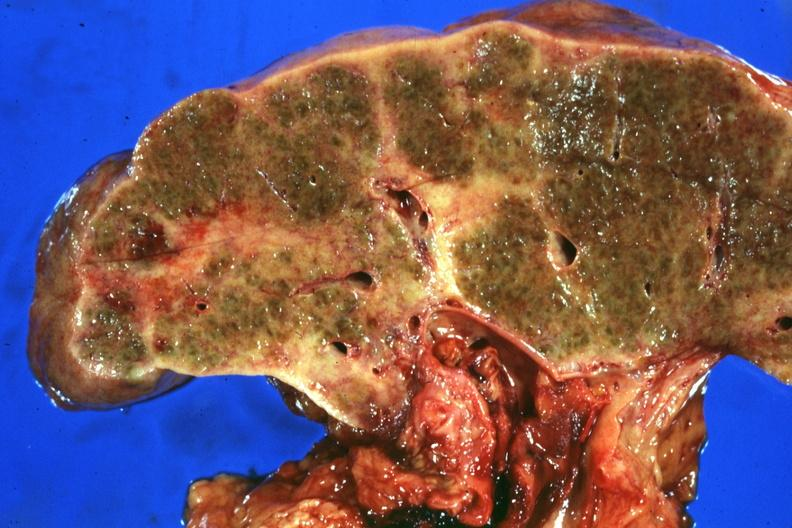s exact cause present?
Answer the question using a single word or phrase. No 